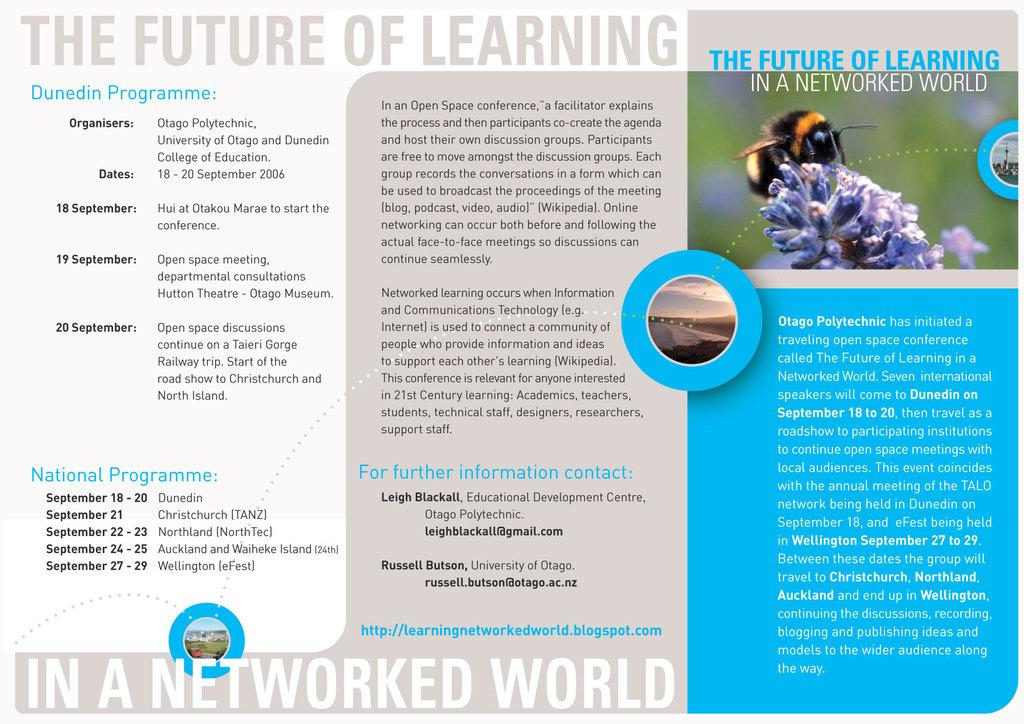What type of visual is the image? The image is a poster. What is depicted in the picture on the poster? There is a picture of an insect on a flower on the poster. What else can be found on the poster besides the picture? There is text written on the poster. How many rows of corn can be seen in the image? There is no corn present in the image, as it is a poster featuring a picture of an insect on a flower. 